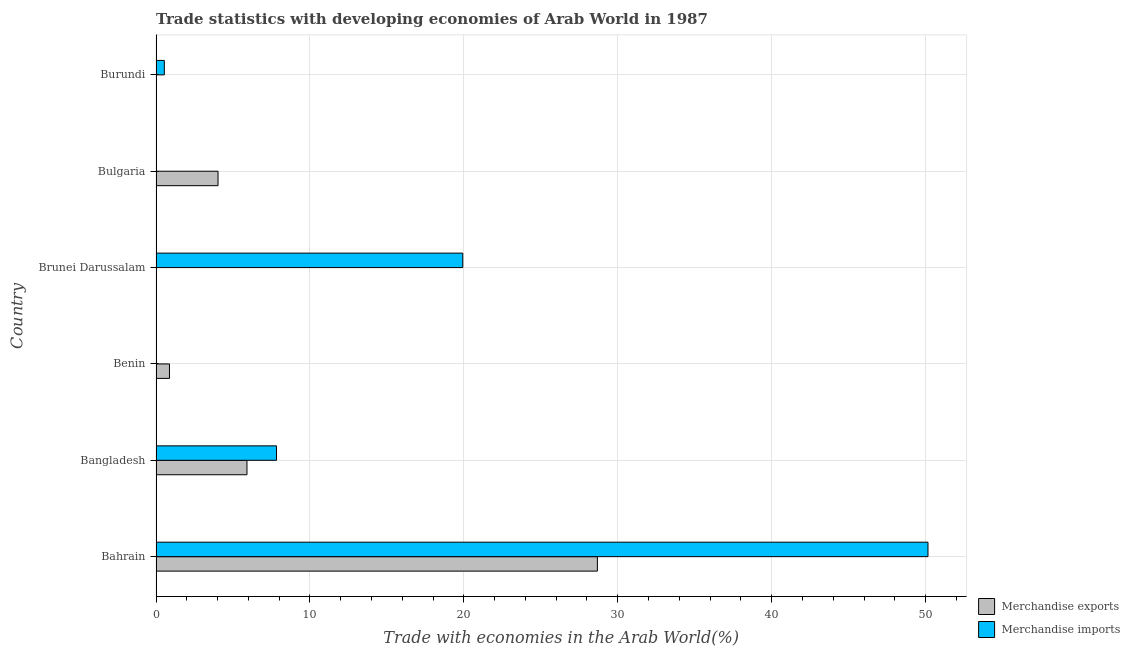How many groups of bars are there?
Give a very brief answer. 6. Are the number of bars per tick equal to the number of legend labels?
Your answer should be very brief. Yes. How many bars are there on the 2nd tick from the top?
Ensure brevity in your answer.  2. How many bars are there on the 4th tick from the bottom?
Your response must be concise. 2. What is the label of the 6th group of bars from the top?
Ensure brevity in your answer.  Bahrain. In how many cases, is the number of bars for a given country not equal to the number of legend labels?
Make the answer very short. 0. What is the merchandise exports in Bahrain?
Keep it short and to the point. 28.68. Across all countries, what is the maximum merchandise exports?
Ensure brevity in your answer.  28.68. Across all countries, what is the minimum merchandise imports?
Your answer should be compact. 0. In which country was the merchandise imports maximum?
Your response must be concise. Bahrain. In which country was the merchandise imports minimum?
Give a very brief answer. Benin. What is the total merchandise imports in the graph?
Your answer should be very brief. 78.48. What is the difference between the merchandise exports in Bahrain and that in Benin?
Give a very brief answer. 27.8. What is the difference between the merchandise exports in Benin and the merchandise imports in Bahrain?
Your answer should be compact. -49.28. What is the average merchandise exports per country?
Your answer should be very brief. 6.58. What is the difference between the merchandise exports and merchandise imports in Burundi?
Keep it short and to the point. -0.52. In how many countries, is the merchandise exports greater than 40 %?
Your answer should be very brief. 0. What is the ratio of the merchandise exports in Brunei Darussalam to that in Burundi?
Keep it short and to the point. 0.07. Is the merchandise imports in Benin less than that in Brunei Darussalam?
Make the answer very short. Yes. What is the difference between the highest and the second highest merchandise exports?
Make the answer very short. 22.77. What is the difference between the highest and the lowest merchandise exports?
Provide a short and direct response. 28.67. What does the 2nd bar from the top in Brunei Darussalam represents?
Your response must be concise. Merchandise exports. How many bars are there?
Your response must be concise. 12. Are all the bars in the graph horizontal?
Your answer should be compact. Yes. How many countries are there in the graph?
Make the answer very short. 6. What is the difference between two consecutive major ticks on the X-axis?
Your answer should be compact. 10. Are the values on the major ticks of X-axis written in scientific E-notation?
Your response must be concise. No. How are the legend labels stacked?
Ensure brevity in your answer.  Vertical. What is the title of the graph?
Provide a succinct answer. Trade statistics with developing economies of Arab World in 1987. Does "Non-residents" appear as one of the legend labels in the graph?
Ensure brevity in your answer.  No. What is the label or title of the X-axis?
Your answer should be compact. Trade with economies in the Arab World(%). What is the label or title of the Y-axis?
Your response must be concise. Country. What is the Trade with economies in the Arab World(%) of Merchandise exports in Bahrain?
Ensure brevity in your answer.  28.68. What is the Trade with economies in the Arab World(%) in Merchandise imports in Bahrain?
Ensure brevity in your answer.  50.16. What is the Trade with economies in the Arab World(%) in Merchandise exports in Bangladesh?
Provide a succinct answer. 5.91. What is the Trade with economies in the Arab World(%) of Merchandise imports in Bangladesh?
Offer a terse response. 7.83. What is the Trade with economies in the Arab World(%) of Merchandise exports in Benin?
Offer a very short reply. 0.87. What is the Trade with economies in the Arab World(%) of Merchandise imports in Benin?
Give a very brief answer. 0. What is the Trade with economies in the Arab World(%) in Merchandise exports in Brunei Darussalam?
Provide a succinct answer. 0. What is the Trade with economies in the Arab World(%) of Merchandise imports in Brunei Darussalam?
Offer a terse response. 19.93. What is the Trade with economies in the Arab World(%) of Merchandise exports in Bulgaria?
Offer a terse response. 4.03. What is the Trade with economies in the Arab World(%) of Merchandise imports in Bulgaria?
Offer a terse response. 0.02. What is the Trade with economies in the Arab World(%) in Merchandise exports in Burundi?
Ensure brevity in your answer.  0.02. What is the Trade with economies in the Arab World(%) of Merchandise imports in Burundi?
Provide a succinct answer. 0.54. Across all countries, what is the maximum Trade with economies in the Arab World(%) of Merchandise exports?
Your answer should be compact. 28.68. Across all countries, what is the maximum Trade with economies in the Arab World(%) in Merchandise imports?
Provide a short and direct response. 50.16. Across all countries, what is the minimum Trade with economies in the Arab World(%) in Merchandise exports?
Provide a short and direct response. 0. Across all countries, what is the minimum Trade with economies in the Arab World(%) of Merchandise imports?
Provide a short and direct response. 0. What is the total Trade with economies in the Arab World(%) in Merchandise exports in the graph?
Make the answer very short. 39.51. What is the total Trade with economies in the Arab World(%) of Merchandise imports in the graph?
Give a very brief answer. 78.48. What is the difference between the Trade with economies in the Arab World(%) in Merchandise exports in Bahrain and that in Bangladesh?
Make the answer very short. 22.77. What is the difference between the Trade with economies in the Arab World(%) in Merchandise imports in Bahrain and that in Bangladesh?
Your response must be concise. 42.33. What is the difference between the Trade with economies in the Arab World(%) in Merchandise exports in Bahrain and that in Benin?
Keep it short and to the point. 27.8. What is the difference between the Trade with economies in the Arab World(%) of Merchandise imports in Bahrain and that in Benin?
Your response must be concise. 50.15. What is the difference between the Trade with economies in the Arab World(%) in Merchandise exports in Bahrain and that in Brunei Darussalam?
Ensure brevity in your answer.  28.67. What is the difference between the Trade with economies in the Arab World(%) in Merchandise imports in Bahrain and that in Brunei Darussalam?
Your response must be concise. 30.23. What is the difference between the Trade with economies in the Arab World(%) of Merchandise exports in Bahrain and that in Bulgaria?
Ensure brevity in your answer.  24.65. What is the difference between the Trade with economies in the Arab World(%) of Merchandise imports in Bahrain and that in Bulgaria?
Ensure brevity in your answer.  50.13. What is the difference between the Trade with economies in the Arab World(%) in Merchandise exports in Bahrain and that in Burundi?
Your answer should be compact. 28.65. What is the difference between the Trade with economies in the Arab World(%) in Merchandise imports in Bahrain and that in Burundi?
Keep it short and to the point. 49.62. What is the difference between the Trade with economies in the Arab World(%) in Merchandise exports in Bangladesh and that in Benin?
Your response must be concise. 5.04. What is the difference between the Trade with economies in the Arab World(%) in Merchandise imports in Bangladesh and that in Benin?
Ensure brevity in your answer.  7.83. What is the difference between the Trade with economies in the Arab World(%) of Merchandise exports in Bangladesh and that in Brunei Darussalam?
Keep it short and to the point. 5.91. What is the difference between the Trade with economies in the Arab World(%) of Merchandise imports in Bangladesh and that in Brunei Darussalam?
Give a very brief answer. -12.1. What is the difference between the Trade with economies in the Arab World(%) of Merchandise exports in Bangladesh and that in Bulgaria?
Give a very brief answer. 1.88. What is the difference between the Trade with economies in the Arab World(%) of Merchandise imports in Bangladesh and that in Bulgaria?
Provide a succinct answer. 7.81. What is the difference between the Trade with economies in the Arab World(%) of Merchandise exports in Bangladesh and that in Burundi?
Ensure brevity in your answer.  5.89. What is the difference between the Trade with economies in the Arab World(%) in Merchandise imports in Bangladesh and that in Burundi?
Offer a very short reply. 7.29. What is the difference between the Trade with economies in the Arab World(%) in Merchandise exports in Benin and that in Brunei Darussalam?
Keep it short and to the point. 0.87. What is the difference between the Trade with economies in the Arab World(%) in Merchandise imports in Benin and that in Brunei Darussalam?
Offer a very short reply. -19.93. What is the difference between the Trade with economies in the Arab World(%) of Merchandise exports in Benin and that in Bulgaria?
Ensure brevity in your answer.  -3.16. What is the difference between the Trade with economies in the Arab World(%) of Merchandise imports in Benin and that in Bulgaria?
Your answer should be compact. -0.02. What is the difference between the Trade with economies in the Arab World(%) in Merchandise exports in Benin and that in Burundi?
Offer a terse response. 0.85. What is the difference between the Trade with economies in the Arab World(%) of Merchandise imports in Benin and that in Burundi?
Your response must be concise. -0.54. What is the difference between the Trade with economies in the Arab World(%) in Merchandise exports in Brunei Darussalam and that in Bulgaria?
Offer a very short reply. -4.03. What is the difference between the Trade with economies in the Arab World(%) of Merchandise imports in Brunei Darussalam and that in Bulgaria?
Give a very brief answer. 19.91. What is the difference between the Trade with economies in the Arab World(%) of Merchandise exports in Brunei Darussalam and that in Burundi?
Your response must be concise. -0.02. What is the difference between the Trade with economies in the Arab World(%) of Merchandise imports in Brunei Darussalam and that in Burundi?
Your answer should be compact. 19.39. What is the difference between the Trade with economies in the Arab World(%) of Merchandise exports in Bulgaria and that in Burundi?
Offer a very short reply. 4.01. What is the difference between the Trade with economies in the Arab World(%) in Merchandise imports in Bulgaria and that in Burundi?
Your response must be concise. -0.52. What is the difference between the Trade with economies in the Arab World(%) in Merchandise exports in Bahrain and the Trade with economies in the Arab World(%) in Merchandise imports in Bangladesh?
Ensure brevity in your answer.  20.85. What is the difference between the Trade with economies in the Arab World(%) of Merchandise exports in Bahrain and the Trade with economies in the Arab World(%) of Merchandise imports in Benin?
Offer a terse response. 28.67. What is the difference between the Trade with economies in the Arab World(%) of Merchandise exports in Bahrain and the Trade with economies in the Arab World(%) of Merchandise imports in Brunei Darussalam?
Offer a terse response. 8.75. What is the difference between the Trade with economies in the Arab World(%) of Merchandise exports in Bahrain and the Trade with economies in the Arab World(%) of Merchandise imports in Bulgaria?
Your answer should be very brief. 28.65. What is the difference between the Trade with economies in the Arab World(%) of Merchandise exports in Bahrain and the Trade with economies in the Arab World(%) of Merchandise imports in Burundi?
Provide a short and direct response. 28.14. What is the difference between the Trade with economies in the Arab World(%) in Merchandise exports in Bangladesh and the Trade with economies in the Arab World(%) in Merchandise imports in Benin?
Your response must be concise. 5.91. What is the difference between the Trade with economies in the Arab World(%) of Merchandise exports in Bangladesh and the Trade with economies in the Arab World(%) of Merchandise imports in Brunei Darussalam?
Provide a short and direct response. -14.02. What is the difference between the Trade with economies in the Arab World(%) of Merchandise exports in Bangladesh and the Trade with economies in the Arab World(%) of Merchandise imports in Bulgaria?
Your answer should be very brief. 5.89. What is the difference between the Trade with economies in the Arab World(%) of Merchandise exports in Bangladesh and the Trade with economies in the Arab World(%) of Merchandise imports in Burundi?
Provide a succinct answer. 5.37. What is the difference between the Trade with economies in the Arab World(%) in Merchandise exports in Benin and the Trade with economies in the Arab World(%) in Merchandise imports in Brunei Darussalam?
Provide a short and direct response. -19.06. What is the difference between the Trade with economies in the Arab World(%) of Merchandise exports in Benin and the Trade with economies in the Arab World(%) of Merchandise imports in Bulgaria?
Your response must be concise. 0.85. What is the difference between the Trade with economies in the Arab World(%) in Merchandise exports in Benin and the Trade with economies in the Arab World(%) in Merchandise imports in Burundi?
Your answer should be compact. 0.33. What is the difference between the Trade with economies in the Arab World(%) of Merchandise exports in Brunei Darussalam and the Trade with economies in the Arab World(%) of Merchandise imports in Bulgaria?
Provide a short and direct response. -0.02. What is the difference between the Trade with economies in the Arab World(%) of Merchandise exports in Brunei Darussalam and the Trade with economies in the Arab World(%) of Merchandise imports in Burundi?
Your answer should be compact. -0.54. What is the difference between the Trade with economies in the Arab World(%) in Merchandise exports in Bulgaria and the Trade with economies in the Arab World(%) in Merchandise imports in Burundi?
Your response must be concise. 3.49. What is the average Trade with economies in the Arab World(%) in Merchandise exports per country?
Your answer should be very brief. 6.59. What is the average Trade with economies in the Arab World(%) of Merchandise imports per country?
Your response must be concise. 13.08. What is the difference between the Trade with economies in the Arab World(%) of Merchandise exports and Trade with economies in the Arab World(%) of Merchandise imports in Bahrain?
Give a very brief answer. -21.48. What is the difference between the Trade with economies in the Arab World(%) of Merchandise exports and Trade with economies in the Arab World(%) of Merchandise imports in Bangladesh?
Your response must be concise. -1.92. What is the difference between the Trade with economies in the Arab World(%) in Merchandise exports and Trade with economies in the Arab World(%) in Merchandise imports in Benin?
Your answer should be compact. 0.87. What is the difference between the Trade with economies in the Arab World(%) in Merchandise exports and Trade with economies in the Arab World(%) in Merchandise imports in Brunei Darussalam?
Ensure brevity in your answer.  -19.93. What is the difference between the Trade with economies in the Arab World(%) in Merchandise exports and Trade with economies in the Arab World(%) in Merchandise imports in Bulgaria?
Offer a terse response. 4.01. What is the difference between the Trade with economies in the Arab World(%) of Merchandise exports and Trade with economies in the Arab World(%) of Merchandise imports in Burundi?
Provide a succinct answer. -0.52. What is the ratio of the Trade with economies in the Arab World(%) of Merchandise exports in Bahrain to that in Bangladesh?
Your response must be concise. 4.85. What is the ratio of the Trade with economies in the Arab World(%) of Merchandise imports in Bahrain to that in Bangladesh?
Give a very brief answer. 6.41. What is the ratio of the Trade with economies in the Arab World(%) in Merchandise exports in Bahrain to that in Benin?
Your answer should be very brief. 32.84. What is the ratio of the Trade with economies in the Arab World(%) in Merchandise imports in Bahrain to that in Benin?
Provide a short and direct response. 3.57e+04. What is the ratio of the Trade with economies in the Arab World(%) in Merchandise exports in Bahrain to that in Brunei Darussalam?
Offer a terse response. 1.88e+04. What is the ratio of the Trade with economies in the Arab World(%) of Merchandise imports in Bahrain to that in Brunei Darussalam?
Provide a short and direct response. 2.52. What is the ratio of the Trade with economies in the Arab World(%) of Merchandise exports in Bahrain to that in Bulgaria?
Offer a terse response. 7.12. What is the ratio of the Trade with economies in the Arab World(%) of Merchandise imports in Bahrain to that in Bulgaria?
Your answer should be compact. 2149.81. What is the ratio of the Trade with economies in the Arab World(%) of Merchandise exports in Bahrain to that in Burundi?
Keep it short and to the point. 1254.44. What is the ratio of the Trade with economies in the Arab World(%) in Merchandise imports in Bahrain to that in Burundi?
Your response must be concise. 92.99. What is the ratio of the Trade with economies in the Arab World(%) of Merchandise exports in Bangladesh to that in Benin?
Give a very brief answer. 6.77. What is the ratio of the Trade with economies in the Arab World(%) of Merchandise imports in Bangladesh to that in Benin?
Your response must be concise. 5572.02. What is the ratio of the Trade with economies in the Arab World(%) of Merchandise exports in Bangladesh to that in Brunei Darussalam?
Provide a succinct answer. 3880.3. What is the ratio of the Trade with economies in the Arab World(%) in Merchandise imports in Bangladesh to that in Brunei Darussalam?
Ensure brevity in your answer.  0.39. What is the ratio of the Trade with economies in the Arab World(%) in Merchandise exports in Bangladesh to that in Bulgaria?
Your answer should be very brief. 1.47. What is the ratio of the Trade with economies in the Arab World(%) of Merchandise imports in Bangladesh to that in Bulgaria?
Give a very brief answer. 335.56. What is the ratio of the Trade with economies in the Arab World(%) of Merchandise exports in Bangladesh to that in Burundi?
Provide a succinct answer. 258.5. What is the ratio of the Trade with economies in the Arab World(%) of Merchandise imports in Bangladesh to that in Burundi?
Provide a short and direct response. 14.51. What is the ratio of the Trade with economies in the Arab World(%) of Merchandise exports in Benin to that in Brunei Darussalam?
Make the answer very short. 573.38. What is the ratio of the Trade with economies in the Arab World(%) in Merchandise exports in Benin to that in Bulgaria?
Offer a very short reply. 0.22. What is the ratio of the Trade with economies in the Arab World(%) of Merchandise imports in Benin to that in Bulgaria?
Ensure brevity in your answer.  0.06. What is the ratio of the Trade with economies in the Arab World(%) in Merchandise exports in Benin to that in Burundi?
Provide a succinct answer. 38.2. What is the ratio of the Trade with economies in the Arab World(%) in Merchandise imports in Benin to that in Burundi?
Provide a succinct answer. 0. What is the ratio of the Trade with economies in the Arab World(%) of Merchandise imports in Brunei Darussalam to that in Bulgaria?
Provide a succinct answer. 854.25. What is the ratio of the Trade with economies in the Arab World(%) of Merchandise exports in Brunei Darussalam to that in Burundi?
Provide a succinct answer. 0.07. What is the ratio of the Trade with economies in the Arab World(%) of Merchandise imports in Brunei Darussalam to that in Burundi?
Provide a succinct answer. 36.95. What is the ratio of the Trade with economies in the Arab World(%) of Merchandise exports in Bulgaria to that in Burundi?
Ensure brevity in your answer.  176.23. What is the ratio of the Trade with economies in the Arab World(%) of Merchandise imports in Bulgaria to that in Burundi?
Offer a very short reply. 0.04. What is the difference between the highest and the second highest Trade with economies in the Arab World(%) in Merchandise exports?
Provide a short and direct response. 22.77. What is the difference between the highest and the second highest Trade with economies in the Arab World(%) of Merchandise imports?
Keep it short and to the point. 30.23. What is the difference between the highest and the lowest Trade with economies in the Arab World(%) of Merchandise exports?
Offer a very short reply. 28.67. What is the difference between the highest and the lowest Trade with economies in the Arab World(%) in Merchandise imports?
Offer a very short reply. 50.15. 